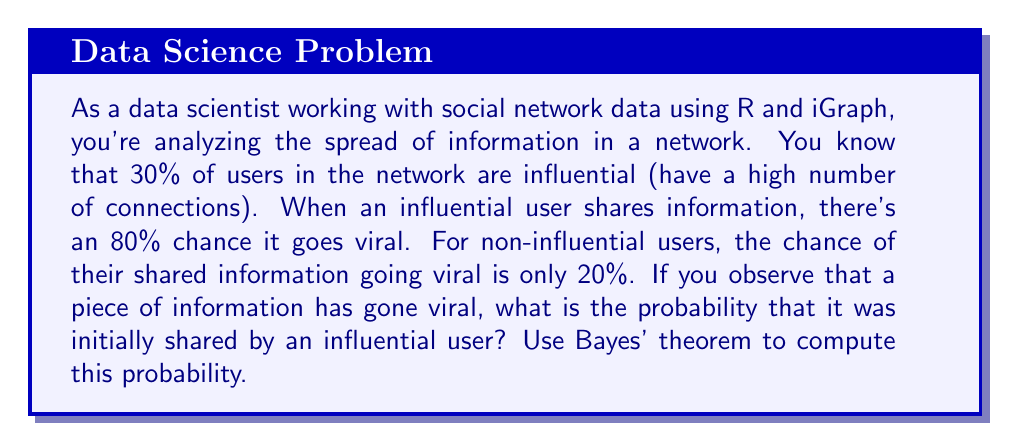Could you help me with this problem? Let's approach this problem using Bayes' theorem. We'll define our events as follows:

$I$: The user is influential
$V$: The information goes viral

We're given the following probabilities:

$P(I) = 0.30$ (30% of users are influential)
$P(V|I) = 0.80$ (80% chance of going viral if shared by an influential user)
$P(V|\text{not }I) = 0.20$ (20% chance of going viral if shared by a non-influential user)

We want to find $P(I|V)$, the probability that the user is influential given that the information went viral.

Bayes' theorem states:

$$P(I|V) = \frac{P(V|I) \cdot P(I)}{P(V)}$$

We need to calculate $P(V)$ using the law of total probability:

$$P(V) = P(V|I) \cdot P(I) + P(V|\text{not }I) \cdot P(\text{not }I)$$

$P(\text{not }I) = 1 - P(I) = 1 - 0.30 = 0.70$

So:

$$P(V) = 0.80 \cdot 0.30 + 0.20 \cdot 0.70 = 0.24 + 0.14 = 0.38$$

Now we can apply Bayes' theorem:

$$P(I|V) = \frac{0.80 \cdot 0.30}{0.38} = \frac{0.24}{0.38} \approx 0.6316$$
Answer: The probability that the viral information was initially shared by an influential user is approximately 0.6316 or 63.16%. 